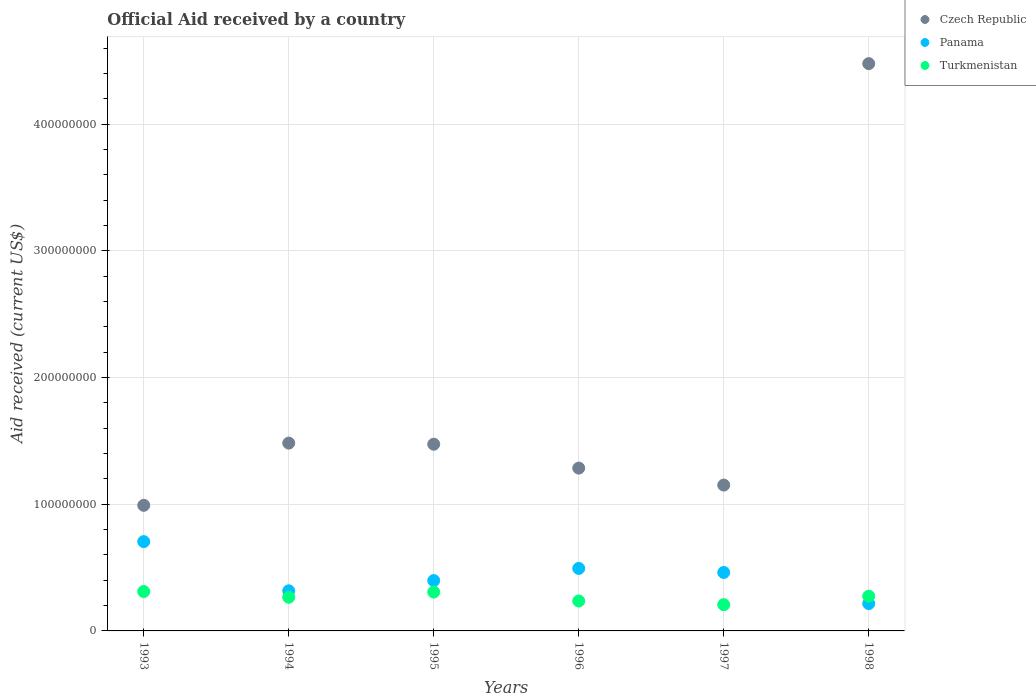What is the net official aid received in Turkmenistan in 1996?
Offer a very short reply. 2.36e+07. Across all years, what is the maximum net official aid received in Czech Republic?
Offer a very short reply. 4.48e+08. Across all years, what is the minimum net official aid received in Czech Republic?
Make the answer very short. 9.92e+07. In which year was the net official aid received in Panama maximum?
Your answer should be very brief. 1993. What is the total net official aid received in Panama in the graph?
Keep it short and to the point. 2.59e+08. What is the difference between the net official aid received in Turkmenistan in 1994 and that in 1997?
Your response must be concise. 5.88e+06. What is the difference between the net official aid received in Panama in 1993 and the net official aid received in Czech Republic in 1997?
Your response must be concise. -4.46e+07. What is the average net official aid received in Czech Republic per year?
Provide a short and direct response. 1.81e+08. In the year 1995, what is the difference between the net official aid received in Panama and net official aid received in Czech Republic?
Make the answer very short. -1.08e+08. What is the ratio of the net official aid received in Turkmenistan in 1993 to that in 1996?
Your answer should be very brief. 1.32. Is the difference between the net official aid received in Panama in 1995 and 1997 greater than the difference between the net official aid received in Czech Republic in 1995 and 1997?
Give a very brief answer. No. What is the difference between the highest and the second highest net official aid received in Czech Republic?
Make the answer very short. 3.00e+08. What is the difference between the highest and the lowest net official aid received in Turkmenistan?
Ensure brevity in your answer.  1.04e+07. Is the net official aid received in Panama strictly less than the net official aid received in Turkmenistan over the years?
Offer a terse response. No. Does the graph contain grids?
Offer a terse response. Yes. How many legend labels are there?
Keep it short and to the point. 3. What is the title of the graph?
Give a very brief answer. Official Aid received by a country. What is the label or title of the X-axis?
Give a very brief answer. Years. What is the label or title of the Y-axis?
Give a very brief answer. Aid received (current US$). What is the Aid received (current US$) in Czech Republic in 1993?
Give a very brief answer. 9.92e+07. What is the Aid received (current US$) in Panama in 1993?
Make the answer very short. 7.05e+07. What is the Aid received (current US$) of Turkmenistan in 1993?
Your response must be concise. 3.11e+07. What is the Aid received (current US$) in Czech Republic in 1994?
Offer a very short reply. 1.48e+08. What is the Aid received (current US$) in Panama in 1994?
Offer a terse response. 3.17e+07. What is the Aid received (current US$) of Turkmenistan in 1994?
Offer a very short reply. 2.66e+07. What is the Aid received (current US$) of Czech Republic in 1995?
Offer a terse response. 1.47e+08. What is the Aid received (current US$) of Panama in 1995?
Your response must be concise. 3.98e+07. What is the Aid received (current US$) in Turkmenistan in 1995?
Offer a terse response. 3.07e+07. What is the Aid received (current US$) in Czech Republic in 1996?
Ensure brevity in your answer.  1.29e+08. What is the Aid received (current US$) of Panama in 1996?
Keep it short and to the point. 4.93e+07. What is the Aid received (current US$) in Turkmenistan in 1996?
Provide a succinct answer. 2.36e+07. What is the Aid received (current US$) in Czech Republic in 1997?
Make the answer very short. 1.15e+08. What is the Aid received (current US$) in Panama in 1997?
Provide a short and direct response. 4.61e+07. What is the Aid received (current US$) in Turkmenistan in 1997?
Your response must be concise. 2.07e+07. What is the Aid received (current US$) of Czech Republic in 1998?
Make the answer very short. 4.48e+08. What is the Aid received (current US$) of Panama in 1998?
Your answer should be compact. 2.16e+07. What is the Aid received (current US$) in Turkmenistan in 1998?
Give a very brief answer. 2.74e+07. Across all years, what is the maximum Aid received (current US$) of Czech Republic?
Provide a short and direct response. 4.48e+08. Across all years, what is the maximum Aid received (current US$) in Panama?
Keep it short and to the point. 7.05e+07. Across all years, what is the maximum Aid received (current US$) of Turkmenistan?
Provide a short and direct response. 3.11e+07. Across all years, what is the minimum Aid received (current US$) of Czech Republic?
Your answer should be compact. 9.92e+07. Across all years, what is the minimum Aid received (current US$) of Panama?
Your answer should be compact. 2.16e+07. Across all years, what is the minimum Aid received (current US$) of Turkmenistan?
Make the answer very short. 2.07e+07. What is the total Aid received (current US$) in Czech Republic in the graph?
Offer a very short reply. 1.09e+09. What is the total Aid received (current US$) in Panama in the graph?
Provide a short and direct response. 2.59e+08. What is the total Aid received (current US$) of Turkmenistan in the graph?
Keep it short and to the point. 1.60e+08. What is the difference between the Aid received (current US$) of Czech Republic in 1993 and that in 1994?
Give a very brief answer. -4.91e+07. What is the difference between the Aid received (current US$) of Panama in 1993 and that in 1994?
Your answer should be compact. 3.88e+07. What is the difference between the Aid received (current US$) in Turkmenistan in 1993 and that in 1994?
Provide a succinct answer. 4.51e+06. What is the difference between the Aid received (current US$) of Czech Republic in 1993 and that in 1995?
Provide a succinct answer. -4.82e+07. What is the difference between the Aid received (current US$) of Panama in 1993 and that in 1995?
Your answer should be compact. 3.08e+07. What is the difference between the Aid received (current US$) of Czech Republic in 1993 and that in 1996?
Your answer should be compact. -2.94e+07. What is the difference between the Aid received (current US$) in Panama in 1993 and that in 1996?
Make the answer very short. 2.12e+07. What is the difference between the Aid received (current US$) in Turkmenistan in 1993 and that in 1996?
Ensure brevity in your answer.  7.45e+06. What is the difference between the Aid received (current US$) of Czech Republic in 1993 and that in 1997?
Make the answer very short. -1.60e+07. What is the difference between the Aid received (current US$) of Panama in 1993 and that in 1997?
Make the answer very short. 2.44e+07. What is the difference between the Aid received (current US$) in Turkmenistan in 1993 and that in 1997?
Keep it short and to the point. 1.04e+07. What is the difference between the Aid received (current US$) in Czech Republic in 1993 and that in 1998?
Keep it short and to the point. -3.49e+08. What is the difference between the Aid received (current US$) of Panama in 1993 and that in 1998?
Ensure brevity in your answer.  4.89e+07. What is the difference between the Aid received (current US$) in Turkmenistan in 1993 and that in 1998?
Make the answer very short. 3.68e+06. What is the difference between the Aid received (current US$) in Czech Republic in 1994 and that in 1995?
Give a very brief answer. 8.90e+05. What is the difference between the Aid received (current US$) in Panama in 1994 and that in 1995?
Your response must be concise. -8.08e+06. What is the difference between the Aid received (current US$) of Turkmenistan in 1994 and that in 1995?
Offer a terse response. -4.12e+06. What is the difference between the Aid received (current US$) of Czech Republic in 1994 and that in 1996?
Your response must be concise. 1.97e+07. What is the difference between the Aid received (current US$) of Panama in 1994 and that in 1996?
Your answer should be compact. -1.76e+07. What is the difference between the Aid received (current US$) of Turkmenistan in 1994 and that in 1996?
Offer a very short reply. 2.94e+06. What is the difference between the Aid received (current US$) of Czech Republic in 1994 and that in 1997?
Provide a short and direct response. 3.31e+07. What is the difference between the Aid received (current US$) of Panama in 1994 and that in 1997?
Offer a terse response. -1.45e+07. What is the difference between the Aid received (current US$) of Turkmenistan in 1994 and that in 1997?
Offer a very short reply. 5.88e+06. What is the difference between the Aid received (current US$) of Czech Republic in 1994 and that in 1998?
Offer a very short reply. -3.00e+08. What is the difference between the Aid received (current US$) in Panama in 1994 and that in 1998?
Your answer should be very brief. 1.01e+07. What is the difference between the Aid received (current US$) of Turkmenistan in 1994 and that in 1998?
Provide a succinct answer. -8.30e+05. What is the difference between the Aid received (current US$) in Czech Republic in 1995 and that in 1996?
Your answer should be very brief. 1.88e+07. What is the difference between the Aid received (current US$) of Panama in 1995 and that in 1996?
Provide a short and direct response. -9.57e+06. What is the difference between the Aid received (current US$) of Turkmenistan in 1995 and that in 1996?
Offer a terse response. 7.06e+06. What is the difference between the Aid received (current US$) in Czech Republic in 1995 and that in 1997?
Give a very brief answer. 3.22e+07. What is the difference between the Aid received (current US$) in Panama in 1995 and that in 1997?
Keep it short and to the point. -6.38e+06. What is the difference between the Aid received (current US$) in Turkmenistan in 1995 and that in 1997?
Offer a terse response. 1.00e+07. What is the difference between the Aid received (current US$) of Czech Republic in 1995 and that in 1998?
Ensure brevity in your answer.  -3.00e+08. What is the difference between the Aid received (current US$) in Panama in 1995 and that in 1998?
Keep it short and to the point. 1.82e+07. What is the difference between the Aid received (current US$) of Turkmenistan in 1995 and that in 1998?
Give a very brief answer. 3.29e+06. What is the difference between the Aid received (current US$) of Czech Republic in 1996 and that in 1997?
Your response must be concise. 1.34e+07. What is the difference between the Aid received (current US$) of Panama in 1996 and that in 1997?
Provide a succinct answer. 3.19e+06. What is the difference between the Aid received (current US$) in Turkmenistan in 1996 and that in 1997?
Offer a terse response. 2.94e+06. What is the difference between the Aid received (current US$) of Czech Republic in 1996 and that in 1998?
Your answer should be compact. -3.19e+08. What is the difference between the Aid received (current US$) of Panama in 1996 and that in 1998?
Your response must be concise. 2.77e+07. What is the difference between the Aid received (current US$) of Turkmenistan in 1996 and that in 1998?
Give a very brief answer. -3.77e+06. What is the difference between the Aid received (current US$) of Czech Republic in 1997 and that in 1998?
Offer a terse response. -3.33e+08. What is the difference between the Aid received (current US$) of Panama in 1997 and that in 1998?
Your answer should be very brief. 2.46e+07. What is the difference between the Aid received (current US$) in Turkmenistan in 1997 and that in 1998?
Keep it short and to the point. -6.71e+06. What is the difference between the Aid received (current US$) in Czech Republic in 1993 and the Aid received (current US$) in Panama in 1994?
Keep it short and to the point. 6.75e+07. What is the difference between the Aid received (current US$) in Czech Republic in 1993 and the Aid received (current US$) in Turkmenistan in 1994?
Ensure brevity in your answer.  7.26e+07. What is the difference between the Aid received (current US$) in Panama in 1993 and the Aid received (current US$) in Turkmenistan in 1994?
Your response must be concise. 4.39e+07. What is the difference between the Aid received (current US$) in Czech Republic in 1993 and the Aid received (current US$) in Panama in 1995?
Offer a terse response. 5.94e+07. What is the difference between the Aid received (current US$) of Czech Republic in 1993 and the Aid received (current US$) of Turkmenistan in 1995?
Offer a terse response. 6.84e+07. What is the difference between the Aid received (current US$) in Panama in 1993 and the Aid received (current US$) in Turkmenistan in 1995?
Provide a short and direct response. 3.98e+07. What is the difference between the Aid received (current US$) of Czech Republic in 1993 and the Aid received (current US$) of Panama in 1996?
Offer a terse response. 4.98e+07. What is the difference between the Aid received (current US$) in Czech Republic in 1993 and the Aid received (current US$) in Turkmenistan in 1996?
Provide a succinct answer. 7.55e+07. What is the difference between the Aid received (current US$) of Panama in 1993 and the Aid received (current US$) of Turkmenistan in 1996?
Give a very brief answer. 4.69e+07. What is the difference between the Aid received (current US$) of Czech Republic in 1993 and the Aid received (current US$) of Panama in 1997?
Ensure brevity in your answer.  5.30e+07. What is the difference between the Aid received (current US$) in Czech Republic in 1993 and the Aid received (current US$) in Turkmenistan in 1997?
Provide a short and direct response. 7.84e+07. What is the difference between the Aid received (current US$) of Panama in 1993 and the Aid received (current US$) of Turkmenistan in 1997?
Offer a terse response. 4.98e+07. What is the difference between the Aid received (current US$) of Czech Republic in 1993 and the Aid received (current US$) of Panama in 1998?
Keep it short and to the point. 7.76e+07. What is the difference between the Aid received (current US$) of Czech Republic in 1993 and the Aid received (current US$) of Turkmenistan in 1998?
Provide a short and direct response. 7.17e+07. What is the difference between the Aid received (current US$) in Panama in 1993 and the Aid received (current US$) in Turkmenistan in 1998?
Provide a short and direct response. 4.31e+07. What is the difference between the Aid received (current US$) of Czech Republic in 1994 and the Aid received (current US$) of Panama in 1995?
Your answer should be very brief. 1.09e+08. What is the difference between the Aid received (current US$) in Czech Republic in 1994 and the Aid received (current US$) in Turkmenistan in 1995?
Offer a very short reply. 1.18e+08. What is the difference between the Aid received (current US$) in Panama in 1994 and the Aid received (current US$) in Turkmenistan in 1995?
Your answer should be compact. 9.70e+05. What is the difference between the Aid received (current US$) of Czech Republic in 1994 and the Aid received (current US$) of Panama in 1996?
Provide a succinct answer. 9.90e+07. What is the difference between the Aid received (current US$) in Czech Republic in 1994 and the Aid received (current US$) in Turkmenistan in 1996?
Keep it short and to the point. 1.25e+08. What is the difference between the Aid received (current US$) of Panama in 1994 and the Aid received (current US$) of Turkmenistan in 1996?
Your answer should be very brief. 8.03e+06. What is the difference between the Aid received (current US$) of Czech Republic in 1994 and the Aid received (current US$) of Panama in 1997?
Your answer should be very brief. 1.02e+08. What is the difference between the Aid received (current US$) of Czech Republic in 1994 and the Aid received (current US$) of Turkmenistan in 1997?
Offer a terse response. 1.28e+08. What is the difference between the Aid received (current US$) of Panama in 1994 and the Aid received (current US$) of Turkmenistan in 1997?
Provide a short and direct response. 1.10e+07. What is the difference between the Aid received (current US$) in Czech Republic in 1994 and the Aid received (current US$) in Panama in 1998?
Ensure brevity in your answer.  1.27e+08. What is the difference between the Aid received (current US$) of Czech Republic in 1994 and the Aid received (current US$) of Turkmenistan in 1998?
Provide a succinct answer. 1.21e+08. What is the difference between the Aid received (current US$) in Panama in 1994 and the Aid received (current US$) in Turkmenistan in 1998?
Your answer should be very brief. 4.26e+06. What is the difference between the Aid received (current US$) in Czech Republic in 1995 and the Aid received (current US$) in Panama in 1996?
Your response must be concise. 9.81e+07. What is the difference between the Aid received (current US$) of Czech Republic in 1995 and the Aid received (current US$) of Turkmenistan in 1996?
Offer a very short reply. 1.24e+08. What is the difference between the Aid received (current US$) in Panama in 1995 and the Aid received (current US$) in Turkmenistan in 1996?
Your answer should be very brief. 1.61e+07. What is the difference between the Aid received (current US$) in Czech Republic in 1995 and the Aid received (current US$) in Panama in 1997?
Ensure brevity in your answer.  1.01e+08. What is the difference between the Aid received (current US$) in Czech Republic in 1995 and the Aid received (current US$) in Turkmenistan in 1997?
Offer a terse response. 1.27e+08. What is the difference between the Aid received (current US$) in Panama in 1995 and the Aid received (current US$) in Turkmenistan in 1997?
Your response must be concise. 1.90e+07. What is the difference between the Aid received (current US$) in Czech Republic in 1995 and the Aid received (current US$) in Panama in 1998?
Ensure brevity in your answer.  1.26e+08. What is the difference between the Aid received (current US$) in Czech Republic in 1995 and the Aid received (current US$) in Turkmenistan in 1998?
Provide a succinct answer. 1.20e+08. What is the difference between the Aid received (current US$) of Panama in 1995 and the Aid received (current US$) of Turkmenistan in 1998?
Ensure brevity in your answer.  1.23e+07. What is the difference between the Aid received (current US$) of Czech Republic in 1996 and the Aid received (current US$) of Panama in 1997?
Offer a terse response. 8.24e+07. What is the difference between the Aid received (current US$) of Czech Republic in 1996 and the Aid received (current US$) of Turkmenistan in 1997?
Provide a succinct answer. 1.08e+08. What is the difference between the Aid received (current US$) of Panama in 1996 and the Aid received (current US$) of Turkmenistan in 1997?
Offer a very short reply. 2.86e+07. What is the difference between the Aid received (current US$) of Czech Republic in 1996 and the Aid received (current US$) of Panama in 1998?
Provide a short and direct response. 1.07e+08. What is the difference between the Aid received (current US$) of Czech Republic in 1996 and the Aid received (current US$) of Turkmenistan in 1998?
Offer a terse response. 1.01e+08. What is the difference between the Aid received (current US$) in Panama in 1996 and the Aid received (current US$) in Turkmenistan in 1998?
Offer a terse response. 2.19e+07. What is the difference between the Aid received (current US$) in Czech Republic in 1997 and the Aid received (current US$) in Panama in 1998?
Ensure brevity in your answer.  9.36e+07. What is the difference between the Aid received (current US$) in Czech Republic in 1997 and the Aid received (current US$) in Turkmenistan in 1998?
Offer a terse response. 8.77e+07. What is the difference between the Aid received (current US$) in Panama in 1997 and the Aid received (current US$) in Turkmenistan in 1998?
Keep it short and to the point. 1.87e+07. What is the average Aid received (current US$) of Czech Republic per year?
Provide a succinct answer. 1.81e+08. What is the average Aid received (current US$) in Panama per year?
Ensure brevity in your answer.  4.32e+07. What is the average Aid received (current US$) in Turkmenistan per year?
Make the answer very short. 2.67e+07. In the year 1993, what is the difference between the Aid received (current US$) in Czech Republic and Aid received (current US$) in Panama?
Your answer should be compact. 2.86e+07. In the year 1993, what is the difference between the Aid received (current US$) in Czech Republic and Aid received (current US$) in Turkmenistan?
Make the answer very short. 6.81e+07. In the year 1993, what is the difference between the Aid received (current US$) in Panama and Aid received (current US$) in Turkmenistan?
Provide a succinct answer. 3.94e+07. In the year 1994, what is the difference between the Aid received (current US$) in Czech Republic and Aid received (current US$) in Panama?
Your answer should be compact. 1.17e+08. In the year 1994, what is the difference between the Aid received (current US$) of Czech Republic and Aid received (current US$) of Turkmenistan?
Your answer should be compact. 1.22e+08. In the year 1994, what is the difference between the Aid received (current US$) in Panama and Aid received (current US$) in Turkmenistan?
Keep it short and to the point. 5.09e+06. In the year 1995, what is the difference between the Aid received (current US$) of Czech Republic and Aid received (current US$) of Panama?
Offer a terse response. 1.08e+08. In the year 1995, what is the difference between the Aid received (current US$) in Czech Republic and Aid received (current US$) in Turkmenistan?
Make the answer very short. 1.17e+08. In the year 1995, what is the difference between the Aid received (current US$) of Panama and Aid received (current US$) of Turkmenistan?
Your response must be concise. 9.05e+06. In the year 1996, what is the difference between the Aid received (current US$) of Czech Republic and Aid received (current US$) of Panama?
Offer a very short reply. 7.92e+07. In the year 1996, what is the difference between the Aid received (current US$) in Czech Republic and Aid received (current US$) in Turkmenistan?
Offer a terse response. 1.05e+08. In the year 1996, what is the difference between the Aid received (current US$) in Panama and Aid received (current US$) in Turkmenistan?
Provide a short and direct response. 2.57e+07. In the year 1997, what is the difference between the Aid received (current US$) of Czech Republic and Aid received (current US$) of Panama?
Provide a succinct answer. 6.90e+07. In the year 1997, what is the difference between the Aid received (current US$) in Czech Republic and Aid received (current US$) in Turkmenistan?
Make the answer very short. 9.44e+07. In the year 1997, what is the difference between the Aid received (current US$) in Panama and Aid received (current US$) in Turkmenistan?
Provide a succinct answer. 2.54e+07. In the year 1998, what is the difference between the Aid received (current US$) in Czech Republic and Aid received (current US$) in Panama?
Make the answer very short. 4.26e+08. In the year 1998, what is the difference between the Aid received (current US$) of Czech Republic and Aid received (current US$) of Turkmenistan?
Provide a short and direct response. 4.20e+08. In the year 1998, what is the difference between the Aid received (current US$) of Panama and Aid received (current US$) of Turkmenistan?
Keep it short and to the point. -5.83e+06. What is the ratio of the Aid received (current US$) in Czech Republic in 1993 to that in 1994?
Keep it short and to the point. 0.67. What is the ratio of the Aid received (current US$) in Panama in 1993 to that in 1994?
Your response must be concise. 2.23. What is the ratio of the Aid received (current US$) in Turkmenistan in 1993 to that in 1994?
Provide a short and direct response. 1.17. What is the ratio of the Aid received (current US$) in Czech Republic in 1993 to that in 1995?
Your response must be concise. 0.67. What is the ratio of the Aid received (current US$) in Panama in 1993 to that in 1995?
Your answer should be very brief. 1.77. What is the ratio of the Aid received (current US$) of Turkmenistan in 1993 to that in 1995?
Ensure brevity in your answer.  1.01. What is the ratio of the Aid received (current US$) in Czech Republic in 1993 to that in 1996?
Offer a very short reply. 0.77. What is the ratio of the Aid received (current US$) of Panama in 1993 to that in 1996?
Offer a very short reply. 1.43. What is the ratio of the Aid received (current US$) of Turkmenistan in 1993 to that in 1996?
Give a very brief answer. 1.32. What is the ratio of the Aid received (current US$) of Czech Republic in 1993 to that in 1997?
Your answer should be compact. 0.86. What is the ratio of the Aid received (current US$) in Panama in 1993 to that in 1997?
Your response must be concise. 1.53. What is the ratio of the Aid received (current US$) of Turkmenistan in 1993 to that in 1997?
Ensure brevity in your answer.  1.5. What is the ratio of the Aid received (current US$) of Czech Republic in 1993 to that in 1998?
Keep it short and to the point. 0.22. What is the ratio of the Aid received (current US$) in Panama in 1993 to that in 1998?
Offer a terse response. 3.27. What is the ratio of the Aid received (current US$) in Turkmenistan in 1993 to that in 1998?
Offer a terse response. 1.13. What is the ratio of the Aid received (current US$) in Czech Republic in 1994 to that in 1995?
Provide a succinct answer. 1.01. What is the ratio of the Aid received (current US$) in Panama in 1994 to that in 1995?
Provide a succinct answer. 0.8. What is the ratio of the Aid received (current US$) of Turkmenistan in 1994 to that in 1995?
Provide a short and direct response. 0.87. What is the ratio of the Aid received (current US$) in Czech Republic in 1994 to that in 1996?
Provide a succinct answer. 1.15. What is the ratio of the Aid received (current US$) of Panama in 1994 to that in 1996?
Give a very brief answer. 0.64. What is the ratio of the Aid received (current US$) in Turkmenistan in 1994 to that in 1996?
Provide a succinct answer. 1.12. What is the ratio of the Aid received (current US$) in Czech Republic in 1994 to that in 1997?
Keep it short and to the point. 1.29. What is the ratio of the Aid received (current US$) of Panama in 1994 to that in 1997?
Make the answer very short. 0.69. What is the ratio of the Aid received (current US$) in Turkmenistan in 1994 to that in 1997?
Provide a succinct answer. 1.28. What is the ratio of the Aid received (current US$) of Czech Republic in 1994 to that in 1998?
Offer a terse response. 0.33. What is the ratio of the Aid received (current US$) in Panama in 1994 to that in 1998?
Give a very brief answer. 1.47. What is the ratio of the Aid received (current US$) of Turkmenistan in 1994 to that in 1998?
Provide a short and direct response. 0.97. What is the ratio of the Aid received (current US$) of Czech Republic in 1995 to that in 1996?
Give a very brief answer. 1.15. What is the ratio of the Aid received (current US$) in Panama in 1995 to that in 1996?
Make the answer very short. 0.81. What is the ratio of the Aid received (current US$) in Turkmenistan in 1995 to that in 1996?
Offer a terse response. 1.3. What is the ratio of the Aid received (current US$) in Czech Republic in 1995 to that in 1997?
Make the answer very short. 1.28. What is the ratio of the Aid received (current US$) in Panama in 1995 to that in 1997?
Offer a very short reply. 0.86. What is the ratio of the Aid received (current US$) of Turkmenistan in 1995 to that in 1997?
Offer a very short reply. 1.48. What is the ratio of the Aid received (current US$) in Czech Republic in 1995 to that in 1998?
Provide a short and direct response. 0.33. What is the ratio of the Aid received (current US$) in Panama in 1995 to that in 1998?
Your answer should be very brief. 1.84. What is the ratio of the Aid received (current US$) in Turkmenistan in 1995 to that in 1998?
Give a very brief answer. 1.12. What is the ratio of the Aid received (current US$) of Czech Republic in 1996 to that in 1997?
Your answer should be compact. 1.12. What is the ratio of the Aid received (current US$) in Panama in 1996 to that in 1997?
Ensure brevity in your answer.  1.07. What is the ratio of the Aid received (current US$) of Turkmenistan in 1996 to that in 1997?
Ensure brevity in your answer.  1.14. What is the ratio of the Aid received (current US$) of Czech Republic in 1996 to that in 1998?
Offer a very short reply. 0.29. What is the ratio of the Aid received (current US$) of Panama in 1996 to that in 1998?
Provide a short and direct response. 2.29. What is the ratio of the Aid received (current US$) in Turkmenistan in 1996 to that in 1998?
Make the answer very short. 0.86. What is the ratio of the Aid received (current US$) of Czech Republic in 1997 to that in 1998?
Ensure brevity in your answer.  0.26. What is the ratio of the Aid received (current US$) in Panama in 1997 to that in 1998?
Keep it short and to the point. 2.14. What is the ratio of the Aid received (current US$) of Turkmenistan in 1997 to that in 1998?
Make the answer very short. 0.76. What is the difference between the highest and the second highest Aid received (current US$) of Czech Republic?
Provide a succinct answer. 3.00e+08. What is the difference between the highest and the second highest Aid received (current US$) of Panama?
Provide a succinct answer. 2.12e+07. What is the difference between the highest and the second highest Aid received (current US$) of Turkmenistan?
Make the answer very short. 3.90e+05. What is the difference between the highest and the lowest Aid received (current US$) of Czech Republic?
Your answer should be compact. 3.49e+08. What is the difference between the highest and the lowest Aid received (current US$) in Panama?
Offer a terse response. 4.89e+07. What is the difference between the highest and the lowest Aid received (current US$) of Turkmenistan?
Offer a very short reply. 1.04e+07. 